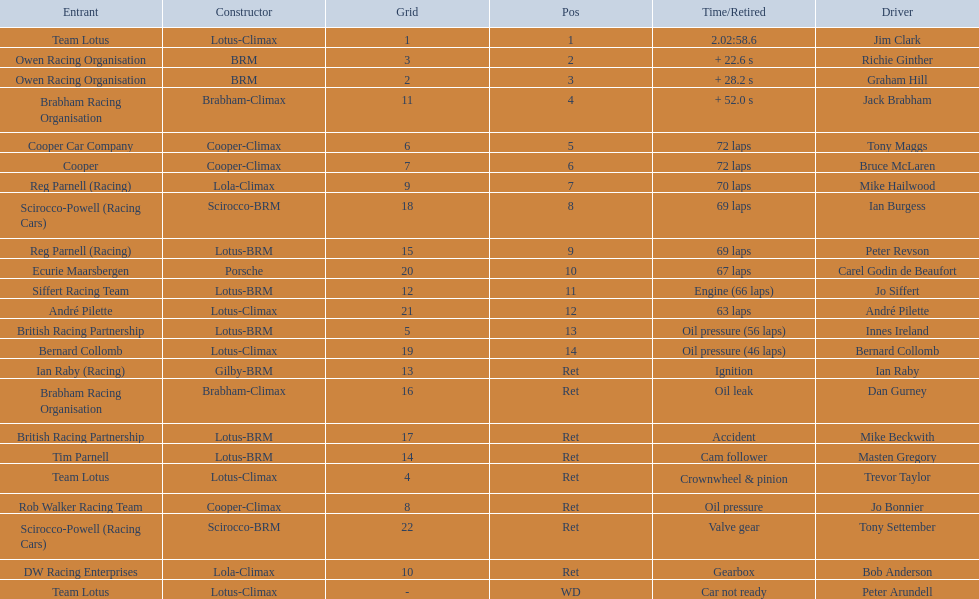Who were the two that that a similar problem? Innes Ireland. What was their common problem? Oil pressure. 